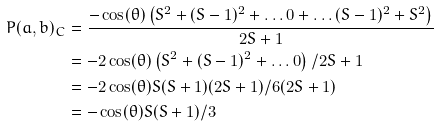<formula> <loc_0><loc_0><loc_500><loc_500>P ( a , b ) _ { C } & = \frac { - \cos ( \theta ) \left ( S ^ { 2 } + ( S - 1 ) ^ { 2 } + \dots 0 + \dots ( S - 1 ) ^ { 2 } + S ^ { 2 } \right ) } { 2 S + 1 } \\ & = - 2 \cos ( \theta ) \left ( S ^ { 2 } + ( S - 1 ) ^ { 2 } + \dots 0 \right ) / 2 S + 1 \\ & = - 2 \cos ( \theta ) S ( S + 1 ) ( 2 S + 1 ) / 6 ( 2 S + 1 ) \\ & = - \cos ( \theta ) S ( S + 1 ) / 3</formula> 